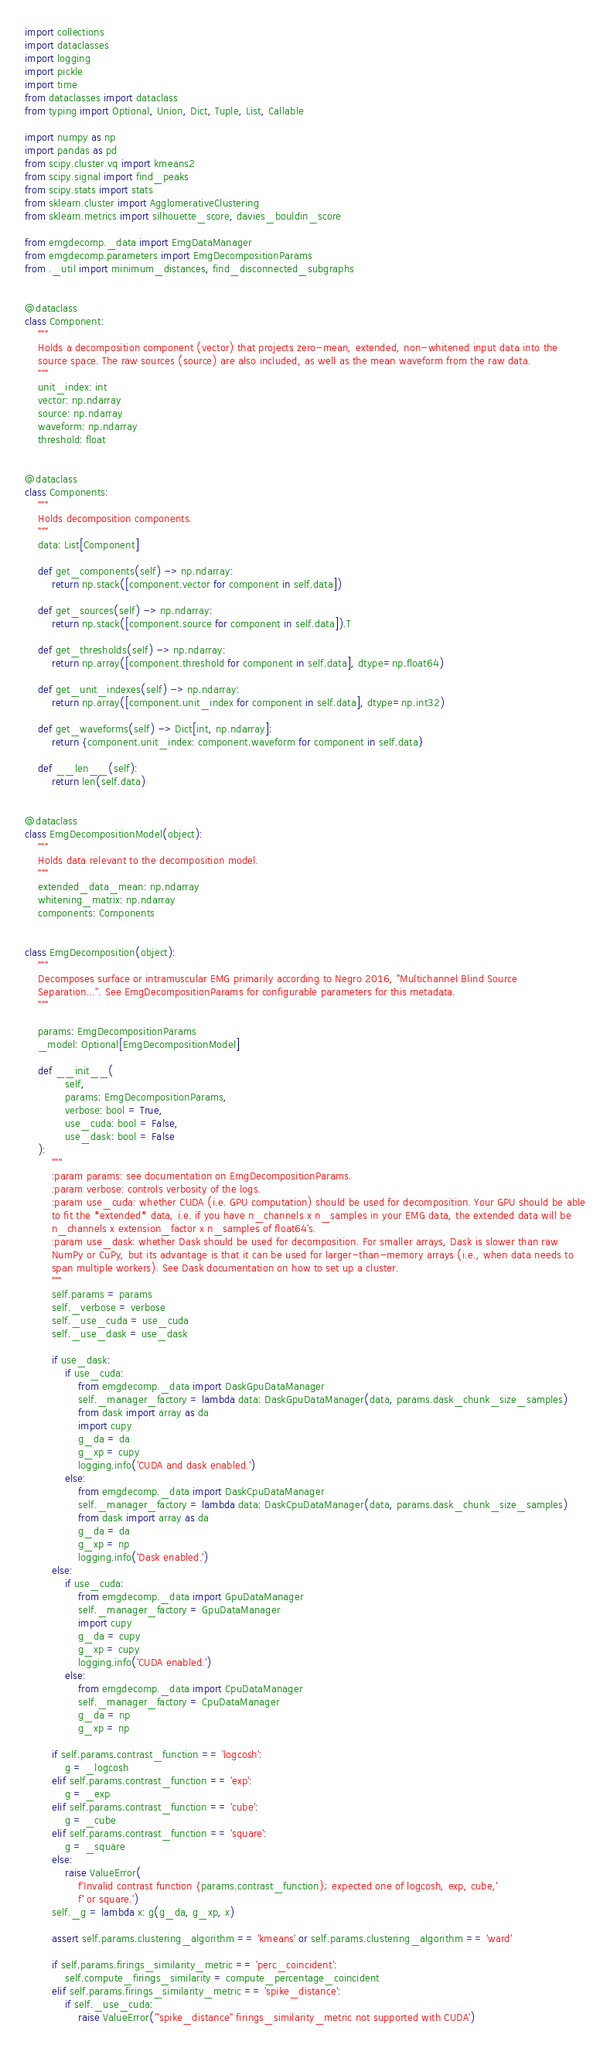<code> <loc_0><loc_0><loc_500><loc_500><_Python_>import collections
import dataclasses
import logging
import pickle
import time
from dataclasses import dataclass
from typing import Optional, Union, Dict, Tuple, List, Callable

import numpy as np
import pandas as pd
from scipy.cluster.vq import kmeans2
from scipy.signal import find_peaks
from scipy.stats import stats
from sklearn.cluster import AgglomerativeClustering
from sklearn.metrics import silhouette_score, davies_bouldin_score

from emgdecomp._data import EmgDataManager
from emgdecomp.parameters import EmgDecompositionParams
from ._util import minimum_distances, find_disconnected_subgraphs


@dataclass
class Component:
    """
    Holds a decomposition component (vector) that projects zero-mean, extended, non-whitened input data into the
    source space. The raw sources (source) are also included, as well as the mean waveform from the raw data.
    """
    unit_index: int
    vector: np.ndarray
    source: np.ndarray
    waveform: np.ndarray
    threshold: float


@dataclass
class Components:
    """
    Holds decomposition components.
    """
    data: List[Component]

    def get_components(self) -> np.ndarray:
        return np.stack([component.vector for component in self.data])

    def get_sources(self) -> np.ndarray:
        return np.stack([component.source for component in self.data]).T

    def get_thresholds(self) -> np.ndarray:
        return np.array([component.threshold for component in self.data], dtype=np.float64)

    def get_unit_indexes(self) -> np.ndarray:
        return np.array([component.unit_index for component in self.data], dtype=np.int32)

    def get_waveforms(self) -> Dict[int, np.ndarray]:
        return {component.unit_index: component.waveform for component in self.data}

    def __len__(self):
        return len(self.data)


@dataclass
class EmgDecompositionModel(object):
    """
    Holds data relevant to the decomposition model.
    """
    extended_data_mean: np.ndarray
    whitening_matrix: np.ndarray
    components: Components


class EmgDecomposition(object):
    """
    Decomposes surface or intramuscular EMG primarily according to Negro 2016, "Multichannel Blind Source
    Separation...". See EmgDecompositionParams for configurable parameters for this metadata.
    """

    params: EmgDecompositionParams
    _model: Optional[EmgDecompositionModel]

    def __init__(
            self,
            params: EmgDecompositionParams,
            verbose: bool = True,
            use_cuda: bool = False,
            use_dask: bool = False
    ):
        """
        :param params: see documentation on EmgDecompositionParams.
        :param verbose: controls verbosity of the logs.
        :param use_cuda: whether CUDA (i.e. GPU computation) should be used for decomposition. Your GPU should be able
        to fit the *extended* data, i.e. if you have n_channels x n_samples in your EMG data, the extended data will be
        n_channels x extension_factor x n_samples of float64's.
        :param use_dask: whether Dask should be used for decomposition. For smaller arrays, Dask is slower than raw
        NumPy or CuPy, but its advantage is that it can be used for larger-than-memory arrays (i.e., when data needs to
        span multiple workers). See Dask documentation on how to set up a cluster.
        """
        self.params = params
        self._verbose = verbose
        self._use_cuda = use_cuda
        self._use_dask = use_dask

        if use_dask:
            if use_cuda:
                from emgdecomp._data import DaskGpuDataManager
                self._manager_factory = lambda data: DaskGpuDataManager(data, params.dask_chunk_size_samples)
                from dask import array as da
                import cupy
                g_da = da
                g_xp = cupy
                logging.info('CUDA and dask enabled.')
            else:
                from emgdecomp._data import DaskCpuDataManager
                self._manager_factory = lambda data: DaskCpuDataManager(data, params.dask_chunk_size_samples)
                from dask import array as da
                g_da = da
                g_xp = np
                logging.info('Dask enabled.')
        else:
            if use_cuda:
                from emgdecomp._data import GpuDataManager
                self._manager_factory = GpuDataManager
                import cupy
                g_da = cupy
                g_xp = cupy
                logging.info('CUDA enabled.')
            else:
                from emgdecomp._data import CpuDataManager
                self._manager_factory = CpuDataManager
                g_da = np
                g_xp = np

        if self.params.contrast_function == 'logcosh':
            g = _logcosh
        elif self.params.contrast_function == 'exp':
            g = _exp
        elif self.params.contrast_function == 'cube':
            g = _cube
        elif self.params.contrast_function == 'square':
            g = _square
        else:
            raise ValueError(
                f'Invalid contrast function {params.contrast_function}; expected one of logcosh, exp, cube,'
                f' or square.')
        self._g = lambda x: g(g_da, g_xp, x)

        assert self.params.clustering_algorithm == 'kmeans' or self.params.clustering_algorithm == 'ward'

        if self.params.firings_similarity_metric == 'perc_coincident':
            self.compute_firings_similarity = compute_percentage_coincident
        elif self.params.firings_similarity_metric == 'spike_distance':
            if self._use_cuda:
                raise ValueError('"spike_distance" firings_similarity_metric not supported with CUDA')</code> 